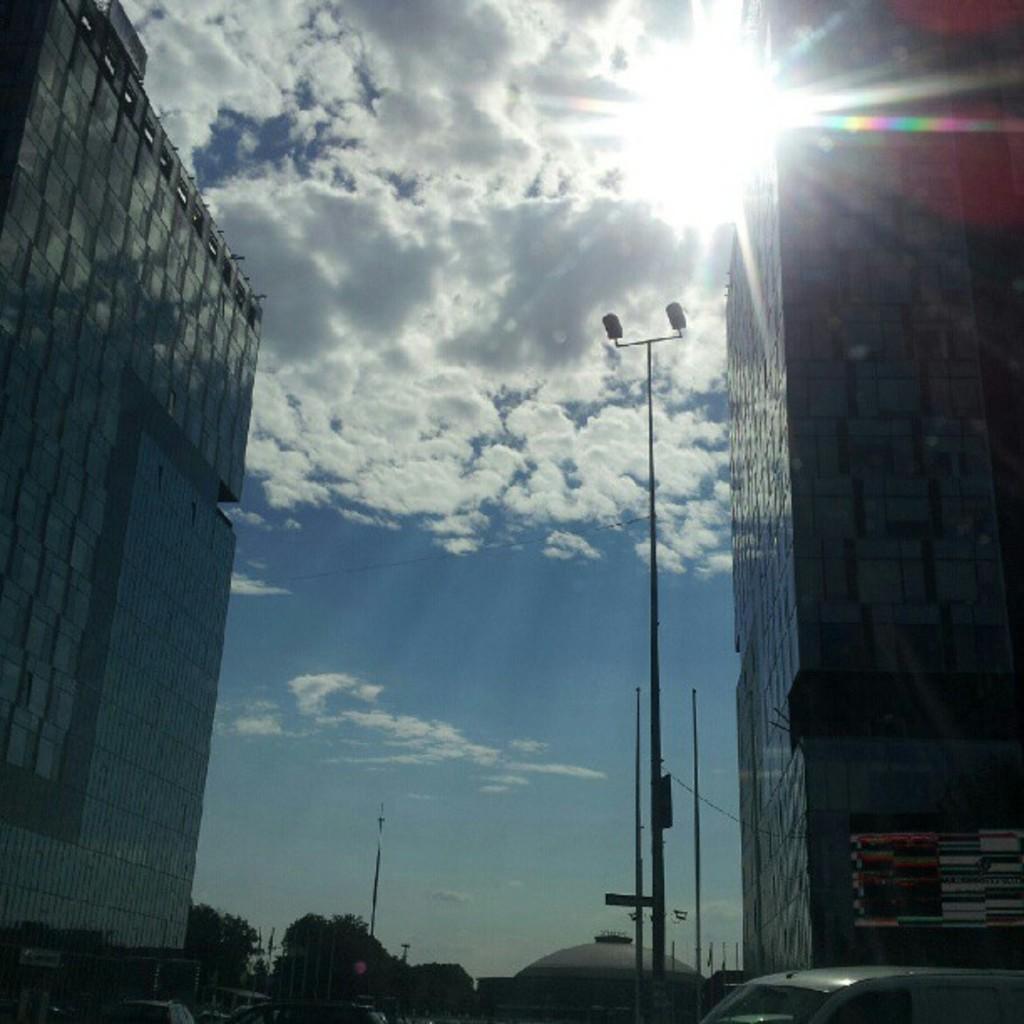Could you give a brief overview of what you see in this image? In the image we can see there are buildings and there are vehicles. There are trees and there are street light poles. There is a cloudy sky. 